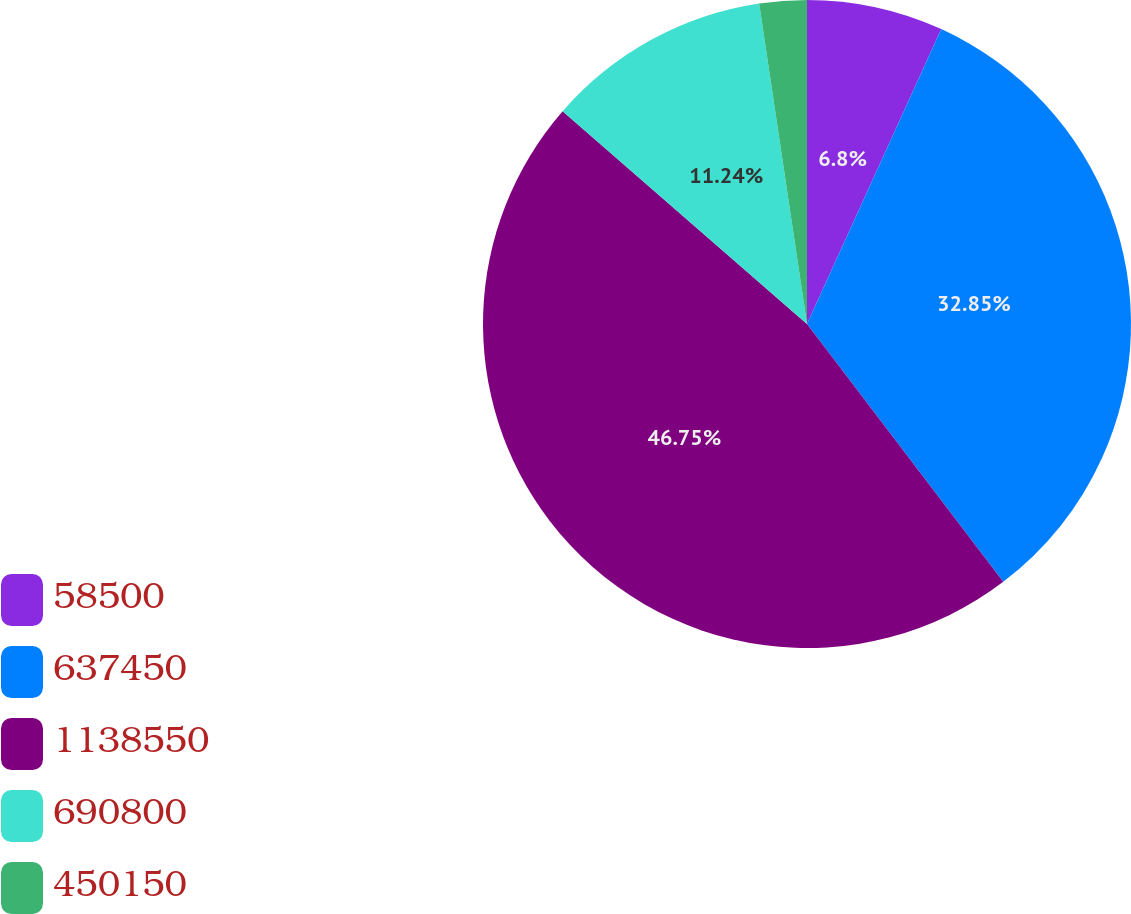Convert chart. <chart><loc_0><loc_0><loc_500><loc_500><pie_chart><fcel>58500<fcel>637450<fcel>1138550<fcel>690800<fcel>450150<nl><fcel>6.8%<fcel>32.85%<fcel>46.76%<fcel>11.24%<fcel>2.36%<nl></chart> 